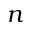<formula> <loc_0><loc_0><loc_500><loc_500>n</formula> 